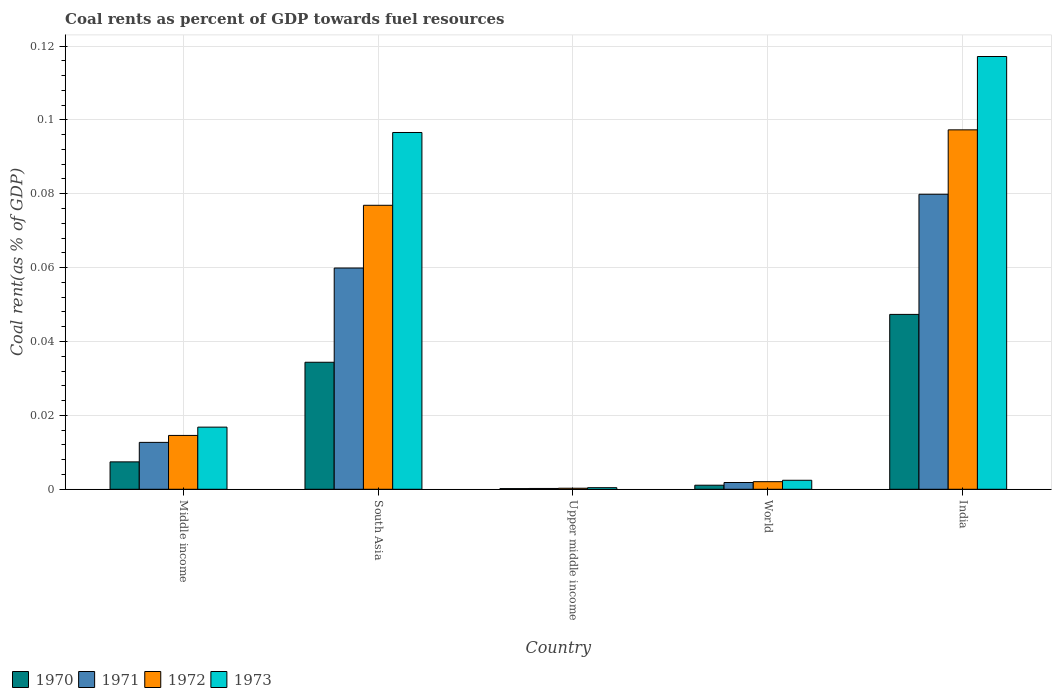How many different coloured bars are there?
Your response must be concise. 4. Are the number of bars per tick equal to the number of legend labels?
Provide a short and direct response. Yes. What is the coal rent in 1973 in Middle income?
Your answer should be compact. 0.02. Across all countries, what is the maximum coal rent in 1971?
Your response must be concise. 0.08. Across all countries, what is the minimum coal rent in 1971?
Your answer should be compact. 0. In which country was the coal rent in 1971 maximum?
Give a very brief answer. India. In which country was the coal rent in 1971 minimum?
Your response must be concise. Upper middle income. What is the total coal rent in 1972 in the graph?
Give a very brief answer. 0.19. What is the difference between the coal rent in 1973 in Middle income and that in South Asia?
Keep it short and to the point. -0.08. What is the difference between the coal rent in 1970 in South Asia and the coal rent in 1972 in India?
Ensure brevity in your answer.  -0.06. What is the average coal rent in 1972 per country?
Give a very brief answer. 0.04. What is the difference between the coal rent of/in 1970 and coal rent of/in 1973 in Middle income?
Your answer should be very brief. -0.01. What is the ratio of the coal rent in 1972 in India to that in Middle income?
Offer a very short reply. 6.68. What is the difference between the highest and the second highest coal rent in 1971?
Your answer should be very brief. 0.07. What is the difference between the highest and the lowest coal rent in 1971?
Offer a terse response. 0.08. In how many countries, is the coal rent in 1971 greater than the average coal rent in 1971 taken over all countries?
Keep it short and to the point. 2. Is the sum of the coal rent in 1973 in India and Upper middle income greater than the maximum coal rent in 1970 across all countries?
Keep it short and to the point. Yes. Is it the case that in every country, the sum of the coal rent in 1970 and coal rent in 1973 is greater than the coal rent in 1971?
Make the answer very short. Yes. How many bars are there?
Make the answer very short. 20. How many countries are there in the graph?
Offer a very short reply. 5. What is the difference between two consecutive major ticks on the Y-axis?
Provide a succinct answer. 0.02. Are the values on the major ticks of Y-axis written in scientific E-notation?
Give a very brief answer. No. Does the graph contain grids?
Offer a very short reply. Yes. How are the legend labels stacked?
Your answer should be very brief. Horizontal. What is the title of the graph?
Ensure brevity in your answer.  Coal rents as percent of GDP towards fuel resources. Does "2012" appear as one of the legend labels in the graph?
Your answer should be compact. No. What is the label or title of the X-axis?
Give a very brief answer. Country. What is the label or title of the Y-axis?
Provide a short and direct response. Coal rent(as % of GDP). What is the Coal rent(as % of GDP) of 1970 in Middle income?
Make the answer very short. 0.01. What is the Coal rent(as % of GDP) in 1971 in Middle income?
Make the answer very short. 0.01. What is the Coal rent(as % of GDP) of 1972 in Middle income?
Provide a succinct answer. 0.01. What is the Coal rent(as % of GDP) in 1973 in Middle income?
Give a very brief answer. 0.02. What is the Coal rent(as % of GDP) in 1970 in South Asia?
Your response must be concise. 0.03. What is the Coal rent(as % of GDP) of 1971 in South Asia?
Keep it short and to the point. 0.06. What is the Coal rent(as % of GDP) in 1972 in South Asia?
Offer a very short reply. 0.08. What is the Coal rent(as % of GDP) of 1973 in South Asia?
Make the answer very short. 0.1. What is the Coal rent(as % of GDP) in 1970 in Upper middle income?
Provide a short and direct response. 0. What is the Coal rent(as % of GDP) in 1971 in Upper middle income?
Offer a very short reply. 0. What is the Coal rent(as % of GDP) of 1972 in Upper middle income?
Provide a succinct answer. 0. What is the Coal rent(as % of GDP) in 1973 in Upper middle income?
Keep it short and to the point. 0. What is the Coal rent(as % of GDP) of 1970 in World?
Provide a succinct answer. 0. What is the Coal rent(as % of GDP) of 1971 in World?
Your response must be concise. 0. What is the Coal rent(as % of GDP) in 1972 in World?
Make the answer very short. 0. What is the Coal rent(as % of GDP) of 1973 in World?
Keep it short and to the point. 0. What is the Coal rent(as % of GDP) in 1970 in India?
Keep it short and to the point. 0.05. What is the Coal rent(as % of GDP) in 1971 in India?
Provide a short and direct response. 0.08. What is the Coal rent(as % of GDP) in 1972 in India?
Your answer should be compact. 0.1. What is the Coal rent(as % of GDP) of 1973 in India?
Provide a short and direct response. 0.12. Across all countries, what is the maximum Coal rent(as % of GDP) in 1970?
Give a very brief answer. 0.05. Across all countries, what is the maximum Coal rent(as % of GDP) in 1971?
Provide a succinct answer. 0.08. Across all countries, what is the maximum Coal rent(as % of GDP) of 1972?
Provide a succinct answer. 0.1. Across all countries, what is the maximum Coal rent(as % of GDP) in 1973?
Keep it short and to the point. 0.12. Across all countries, what is the minimum Coal rent(as % of GDP) of 1970?
Provide a short and direct response. 0. Across all countries, what is the minimum Coal rent(as % of GDP) of 1971?
Give a very brief answer. 0. Across all countries, what is the minimum Coal rent(as % of GDP) of 1972?
Offer a terse response. 0. Across all countries, what is the minimum Coal rent(as % of GDP) of 1973?
Keep it short and to the point. 0. What is the total Coal rent(as % of GDP) in 1970 in the graph?
Your answer should be very brief. 0.09. What is the total Coal rent(as % of GDP) of 1971 in the graph?
Your answer should be very brief. 0.15. What is the total Coal rent(as % of GDP) of 1972 in the graph?
Keep it short and to the point. 0.19. What is the total Coal rent(as % of GDP) of 1973 in the graph?
Keep it short and to the point. 0.23. What is the difference between the Coal rent(as % of GDP) in 1970 in Middle income and that in South Asia?
Your answer should be very brief. -0.03. What is the difference between the Coal rent(as % of GDP) of 1971 in Middle income and that in South Asia?
Your answer should be compact. -0.05. What is the difference between the Coal rent(as % of GDP) in 1972 in Middle income and that in South Asia?
Provide a succinct answer. -0.06. What is the difference between the Coal rent(as % of GDP) in 1973 in Middle income and that in South Asia?
Provide a succinct answer. -0.08. What is the difference between the Coal rent(as % of GDP) in 1970 in Middle income and that in Upper middle income?
Give a very brief answer. 0.01. What is the difference between the Coal rent(as % of GDP) in 1971 in Middle income and that in Upper middle income?
Offer a terse response. 0.01. What is the difference between the Coal rent(as % of GDP) of 1972 in Middle income and that in Upper middle income?
Offer a terse response. 0.01. What is the difference between the Coal rent(as % of GDP) of 1973 in Middle income and that in Upper middle income?
Offer a very short reply. 0.02. What is the difference between the Coal rent(as % of GDP) of 1970 in Middle income and that in World?
Ensure brevity in your answer.  0.01. What is the difference between the Coal rent(as % of GDP) in 1971 in Middle income and that in World?
Keep it short and to the point. 0.01. What is the difference between the Coal rent(as % of GDP) of 1972 in Middle income and that in World?
Make the answer very short. 0.01. What is the difference between the Coal rent(as % of GDP) of 1973 in Middle income and that in World?
Offer a terse response. 0.01. What is the difference between the Coal rent(as % of GDP) in 1970 in Middle income and that in India?
Ensure brevity in your answer.  -0.04. What is the difference between the Coal rent(as % of GDP) in 1971 in Middle income and that in India?
Keep it short and to the point. -0.07. What is the difference between the Coal rent(as % of GDP) in 1972 in Middle income and that in India?
Offer a terse response. -0.08. What is the difference between the Coal rent(as % of GDP) of 1973 in Middle income and that in India?
Offer a very short reply. -0.1. What is the difference between the Coal rent(as % of GDP) of 1970 in South Asia and that in Upper middle income?
Keep it short and to the point. 0.03. What is the difference between the Coal rent(as % of GDP) in 1971 in South Asia and that in Upper middle income?
Make the answer very short. 0.06. What is the difference between the Coal rent(as % of GDP) in 1972 in South Asia and that in Upper middle income?
Keep it short and to the point. 0.08. What is the difference between the Coal rent(as % of GDP) in 1973 in South Asia and that in Upper middle income?
Keep it short and to the point. 0.1. What is the difference between the Coal rent(as % of GDP) of 1971 in South Asia and that in World?
Offer a terse response. 0.06. What is the difference between the Coal rent(as % of GDP) in 1972 in South Asia and that in World?
Your answer should be very brief. 0.07. What is the difference between the Coal rent(as % of GDP) of 1973 in South Asia and that in World?
Give a very brief answer. 0.09. What is the difference between the Coal rent(as % of GDP) of 1970 in South Asia and that in India?
Make the answer very short. -0.01. What is the difference between the Coal rent(as % of GDP) of 1971 in South Asia and that in India?
Make the answer very short. -0.02. What is the difference between the Coal rent(as % of GDP) in 1972 in South Asia and that in India?
Give a very brief answer. -0.02. What is the difference between the Coal rent(as % of GDP) in 1973 in South Asia and that in India?
Your answer should be very brief. -0.02. What is the difference between the Coal rent(as % of GDP) in 1970 in Upper middle income and that in World?
Keep it short and to the point. -0. What is the difference between the Coal rent(as % of GDP) of 1971 in Upper middle income and that in World?
Your response must be concise. -0. What is the difference between the Coal rent(as % of GDP) of 1972 in Upper middle income and that in World?
Give a very brief answer. -0. What is the difference between the Coal rent(as % of GDP) of 1973 in Upper middle income and that in World?
Offer a terse response. -0. What is the difference between the Coal rent(as % of GDP) in 1970 in Upper middle income and that in India?
Give a very brief answer. -0.05. What is the difference between the Coal rent(as % of GDP) in 1971 in Upper middle income and that in India?
Provide a short and direct response. -0.08. What is the difference between the Coal rent(as % of GDP) in 1972 in Upper middle income and that in India?
Provide a short and direct response. -0.1. What is the difference between the Coal rent(as % of GDP) of 1973 in Upper middle income and that in India?
Give a very brief answer. -0.12. What is the difference between the Coal rent(as % of GDP) of 1970 in World and that in India?
Ensure brevity in your answer.  -0.05. What is the difference between the Coal rent(as % of GDP) of 1971 in World and that in India?
Offer a very short reply. -0.08. What is the difference between the Coal rent(as % of GDP) in 1972 in World and that in India?
Your answer should be compact. -0.1. What is the difference between the Coal rent(as % of GDP) in 1973 in World and that in India?
Offer a very short reply. -0.11. What is the difference between the Coal rent(as % of GDP) of 1970 in Middle income and the Coal rent(as % of GDP) of 1971 in South Asia?
Provide a succinct answer. -0.05. What is the difference between the Coal rent(as % of GDP) in 1970 in Middle income and the Coal rent(as % of GDP) in 1972 in South Asia?
Provide a succinct answer. -0.07. What is the difference between the Coal rent(as % of GDP) of 1970 in Middle income and the Coal rent(as % of GDP) of 1973 in South Asia?
Your response must be concise. -0.09. What is the difference between the Coal rent(as % of GDP) in 1971 in Middle income and the Coal rent(as % of GDP) in 1972 in South Asia?
Offer a terse response. -0.06. What is the difference between the Coal rent(as % of GDP) of 1971 in Middle income and the Coal rent(as % of GDP) of 1973 in South Asia?
Offer a very short reply. -0.08. What is the difference between the Coal rent(as % of GDP) in 1972 in Middle income and the Coal rent(as % of GDP) in 1973 in South Asia?
Give a very brief answer. -0.08. What is the difference between the Coal rent(as % of GDP) of 1970 in Middle income and the Coal rent(as % of GDP) of 1971 in Upper middle income?
Provide a short and direct response. 0.01. What is the difference between the Coal rent(as % of GDP) of 1970 in Middle income and the Coal rent(as % of GDP) of 1972 in Upper middle income?
Ensure brevity in your answer.  0.01. What is the difference between the Coal rent(as % of GDP) in 1970 in Middle income and the Coal rent(as % of GDP) in 1973 in Upper middle income?
Provide a short and direct response. 0.01. What is the difference between the Coal rent(as % of GDP) of 1971 in Middle income and the Coal rent(as % of GDP) of 1972 in Upper middle income?
Give a very brief answer. 0.01. What is the difference between the Coal rent(as % of GDP) of 1971 in Middle income and the Coal rent(as % of GDP) of 1973 in Upper middle income?
Your answer should be compact. 0.01. What is the difference between the Coal rent(as % of GDP) of 1972 in Middle income and the Coal rent(as % of GDP) of 1973 in Upper middle income?
Offer a very short reply. 0.01. What is the difference between the Coal rent(as % of GDP) of 1970 in Middle income and the Coal rent(as % of GDP) of 1971 in World?
Make the answer very short. 0.01. What is the difference between the Coal rent(as % of GDP) of 1970 in Middle income and the Coal rent(as % of GDP) of 1972 in World?
Offer a very short reply. 0.01. What is the difference between the Coal rent(as % of GDP) of 1970 in Middle income and the Coal rent(as % of GDP) of 1973 in World?
Your answer should be compact. 0.01. What is the difference between the Coal rent(as % of GDP) of 1971 in Middle income and the Coal rent(as % of GDP) of 1972 in World?
Your answer should be very brief. 0.01. What is the difference between the Coal rent(as % of GDP) in 1971 in Middle income and the Coal rent(as % of GDP) in 1973 in World?
Offer a terse response. 0.01. What is the difference between the Coal rent(as % of GDP) in 1972 in Middle income and the Coal rent(as % of GDP) in 1973 in World?
Ensure brevity in your answer.  0.01. What is the difference between the Coal rent(as % of GDP) in 1970 in Middle income and the Coal rent(as % of GDP) in 1971 in India?
Provide a short and direct response. -0.07. What is the difference between the Coal rent(as % of GDP) of 1970 in Middle income and the Coal rent(as % of GDP) of 1972 in India?
Your answer should be compact. -0.09. What is the difference between the Coal rent(as % of GDP) of 1970 in Middle income and the Coal rent(as % of GDP) of 1973 in India?
Ensure brevity in your answer.  -0.11. What is the difference between the Coal rent(as % of GDP) of 1971 in Middle income and the Coal rent(as % of GDP) of 1972 in India?
Offer a terse response. -0.08. What is the difference between the Coal rent(as % of GDP) in 1971 in Middle income and the Coal rent(as % of GDP) in 1973 in India?
Your answer should be compact. -0.1. What is the difference between the Coal rent(as % of GDP) of 1972 in Middle income and the Coal rent(as % of GDP) of 1973 in India?
Keep it short and to the point. -0.1. What is the difference between the Coal rent(as % of GDP) of 1970 in South Asia and the Coal rent(as % of GDP) of 1971 in Upper middle income?
Keep it short and to the point. 0.03. What is the difference between the Coal rent(as % of GDP) of 1970 in South Asia and the Coal rent(as % of GDP) of 1972 in Upper middle income?
Keep it short and to the point. 0.03. What is the difference between the Coal rent(as % of GDP) in 1970 in South Asia and the Coal rent(as % of GDP) in 1973 in Upper middle income?
Provide a succinct answer. 0.03. What is the difference between the Coal rent(as % of GDP) of 1971 in South Asia and the Coal rent(as % of GDP) of 1972 in Upper middle income?
Offer a very short reply. 0.06. What is the difference between the Coal rent(as % of GDP) of 1971 in South Asia and the Coal rent(as % of GDP) of 1973 in Upper middle income?
Offer a very short reply. 0.06. What is the difference between the Coal rent(as % of GDP) of 1972 in South Asia and the Coal rent(as % of GDP) of 1973 in Upper middle income?
Your response must be concise. 0.08. What is the difference between the Coal rent(as % of GDP) in 1970 in South Asia and the Coal rent(as % of GDP) in 1971 in World?
Give a very brief answer. 0.03. What is the difference between the Coal rent(as % of GDP) of 1970 in South Asia and the Coal rent(as % of GDP) of 1972 in World?
Your answer should be compact. 0.03. What is the difference between the Coal rent(as % of GDP) in 1970 in South Asia and the Coal rent(as % of GDP) in 1973 in World?
Your answer should be compact. 0.03. What is the difference between the Coal rent(as % of GDP) of 1971 in South Asia and the Coal rent(as % of GDP) of 1972 in World?
Ensure brevity in your answer.  0.06. What is the difference between the Coal rent(as % of GDP) in 1971 in South Asia and the Coal rent(as % of GDP) in 1973 in World?
Provide a succinct answer. 0.06. What is the difference between the Coal rent(as % of GDP) of 1972 in South Asia and the Coal rent(as % of GDP) of 1973 in World?
Offer a terse response. 0.07. What is the difference between the Coal rent(as % of GDP) in 1970 in South Asia and the Coal rent(as % of GDP) in 1971 in India?
Keep it short and to the point. -0.05. What is the difference between the Coal rent(as % of GDP) of 1970 in South Asia and the Coal rent(as % of GDP) of 1972 in India?
Make the answer very short. -0.06. What is the difference between the Coal rent(as % of GDP) in 1970 in South Asia and the Coal rent(as % of GDP) in 1973 in India?
Offer a very short reply. -0.08. What is the difference between the Coal rent(as % of GDP) of 1971 in South Asia and the Coal rent(as % of GDP) of 1972 in India?
Offer a terse response. -0.04. What is the difference between the Coal rent(as % of GDP) of 1971 in South Asia and the Coal rent(as % of GDP) of 1973 in India?
Give a very brief answer. -0.06. What is the difference between the Coal rent(as % of GDP) in 1972 in South Asia and the Coal rent(as % of GDP) in 1973 in India?
Your response must be concise. -0.04. What is the difference between the Coal rent(as % of GDP) of 1970 in Upper middle income and the Coal rent(as % of GDP) of 1971 in World?
Ensure brevity in your answer.  -0. What is the difference between the Coal rent(as % of GDP) of 1970 in Upper middle income and the Coal rent(as % of GDP) of 1972 in World?
Offer a terse response. -0. What is the difference between the Coal rent(as % of GDP) in 1970 in Upper middle income and the Coal rent(as % of GDP) in 1973 in World?
Provide a short and direct response. -0. What is the difference between the Coal rent(as % of GDP) of 1971 in Upper middle income and the Coal rent(as % of GDP) of 1972 in World?
Make the answer very short. -0. What is the difference between the Coal rent(as % of GDP) in 1971 in Upper middle income and the Coal rent(as % of GDP) in 1973 in World?
Give a very brief answer. -0. What is the difference between the Coal rent(as % of GDP) of 1972 in Upper middle income and the Coal rent(as % of GDP) of 1973 in World?
Give a very brief answer. -0. What is the difference between the Coal rent(as % of GDP) of 1970 in Upper middle income and the Coal rent(as % of GDP) of 1971 in India?
Provide a short and direct response. -0.08. What is the difference between the Coal rent(as % of GDP) of 1970 in Upper middle income and the Coal rent(as % of GDP) of 1972 in India?
Make the answer very short. -0.1. What is the difference between the Coal rent(as % of GDP) of 1970 in Upper middle income and the Coal rent(as % of GDP) of 1973 in India?
Offer a terse response. -0.12. What is the difference between the Coal rent(as % of GDP) in 1971 in Upper middle income and the Coal rent(as % of GDP) in 1972 in India?
Ensure brevity in your answer.  -0.1. What is the difference between the Coal rent(as % of GDP) of 1971 in Upper middle income and the Coal rent(as % of GDP) of 1973 in India?
Keep it short and to the point. -0.12. What is the difference between the Coal rent(as % of GDP) of 1972 in Upper middle income and the Coal rent(as % of GDP) of 1973 in India?
Give a very brief answer. -0.12. What is the difference between the Coal rent(as % of GDP) of 1970 in World and the Coal rent(as % of GDP) of 1971 in India?
Ensure brevity in your answer.  -0.08. What is the difference between the Coal rent(as % of GDP) in 1970 in World and the Coal rent(as % of GDP) in 1972 in India?
Your answer should be compact. -0.1. What is the difference between the Coal rent(as % of GDP) in 1970 in World and the Coal rent(as % of GDP) in 1973 in India?
Ensure brevity in your answer.  -0.12. What is the difference between the Coal rent(as % of GDP) in 1971 in World and the Coal rent(as % of GDP) in 1972 in India?
Your response must be concise. -0.1. What is the difference between the Coal rent(as % of GDP) in 1971 in World and the Coal rent(as % of GDP) in 1973 in India?
Ensure brevity in your answer.  -0.12. What is the difference between the Coal rent(as % of GDP) in 1972 in World and the Coal rent(as % of GDP) in 1973 in India?
Ensure brevity in your answer.  -0.12. What is the average Coal rent(as % of GDP) in 1970 per country?
Your answer should be compact. 0.02. What is the average Coal rent(as % of GDP) of 1971 per country?
Provide a succinct answer. 0.03. What is the average Coal rent(as % of GDP) of 1972 per country?
Make the answer very short. 0.04. What is the average Coal rent(as % of GDP) in 1973 per country?
Offer a terse response. 0.05. What is the difference between the Coal rent(as % of GDP) in 1970 and Coal rent(as % of GDP) in 1971 in Middle income?
Your answer should be very brief. -0.01. What is the difference between the Coal rent(as % of GDP) of 1970 and Coal rent(as % of GDP) of 1972 in Middle income?
Provide a short and direct response. -0.01. What is the difference between the Coal rent(as % of GDP) in 1970 and Coal rent(as % of GDP) in 1973 in Middle income?
Keep it short and to the point. -0.01. What is the difference between the Coal rent(as % of GDP) in 1971 and Coal rent(as % of GDP) in 1972 in Middle income?
Your answer should be compact. -0. What is the difference between the Coal rent(as % of GDP) of 1971 and Coal rent(as % of GDP) of 1973 in Middle income?
Your answer should be compact. -0. What is the difference between the Coal rent(as % of GDP) in 1972 and Coal rent(as % of GDP) in 1973 in Middle income?
Make the answer very short. -0. What is the difference between the Coal rent(as % of GDP) in 1970 and Coal rent(as % of GDP) in 1971 in South Asia?
Provide a short and direct response. -0.03. What is the difference between the Coal rent(as % of GDP) of 1970 and Coal rent(as % of GDP) of 1972 in South Asia?
Make the answer very short. -0.04. What is the difference between the Coal rent(as % of GDP) in 1970 and Coal rent(as % of GDP) in 1973 in South Asia?
Keep it short and to the point. -0.06. What is the difference between the Coal rent(as % of GDP) of 1971 and Coal rent(as % of GDP) of 1972 in South Asia?
Make the answer very short. -0.02. What is the difference between the Coal rent(as % of GDP) of 1971 and Coal rent(as % of GDP) of 1973 in South Asia?
Your response must be concise. -0.04. What is the difference between the Coal rent(as % of GDP) of 1972 and Coal rent(as % of GDP) of 1973 in South Asia?
Your answer should be compact. -0.02. What is the difference between the Coal rent(as % of GDP) of 1970 and Coal rent(as % of GDP) of 1972 in Upper middle income?
Your answer should be very brief. -0. What is the difference between the Coal rent(as % of GDP) in 1970 and Coal rent(as % of GDP) in 1973 in Upper middle income?
Your answer should be very brief. -0. What is the difference between the Coal rent(as % of GDP) in 1971 and Coal rent(as % of GDP) in 1972 in Upper middle income?
Give a very brief answer. -0. What is the difference between the Coal rent(as % of GDP) of 1971 and Coal rent(as % of GDP) of 1973 in Upper middle income?
Provide a succinct answer. -0. What is the difference between the Coal rent(as % of GDP) in 1972 and Coal rent(as % of GDP) in 1973 in Upper middle income?
Offer a very short reply. -0. What is the difference between the Coal rent(as % of GDP) of 1970 and Coal rent(as % of GDP) of 1971 in World?
Your answer should be compact. -0. What is the difference between the Coal rent(as % of GDP) in 1970 and Coal rent(as % of GDP) in 1972 in World?
Provide a succinct answer. -0. What is the difference between the Coal rent(as % of GDP) in 1970 and Coal rent(as % of GDP) in 1973 in World?
Provide a short and direct response. -0. What is the difference between the Coal rent(as % of GDP) of 1971 and Coal rent(as % of GDP) of 1972 in World?
Your answer should be compact. -0. What is the difference between the Coal rent(as % of GDP) of 1971 and Coal rent(as % of GDP) of 1973 in World?
Your answer should be very brief. -0. What is the difference between the Coal rent(as % of GDP) in 1972 and Coal rent(as % of GDP) in 1973 in World?
Keep it short and to the point. -0. What is the difference between the Coal rent(as % of GDP) in 1970 and Coal rent(as % of GDP) in 1971 in India?
Make the answer very short. -0.03. What is the difference between the Coal rent(as % of GDP) of 1970 and Coal rent(as % of GDP) of 1972 in India?
Keep it short and to the point. -0.05. What is the difference between the Coal rent(as % of GDP) in 1970 and Coal rent(as % of GDP) in 1973 in India?
Offer a very short reply. -0.07. What is the difference between the Coal rent(as % of GDP) in 1971 and Coal rent(as % of GDP) in 1972 in India?
Offer a very short reply. -0.02. What is the difference between the Coal rent(as % of GDP) of 1971 and Coal rent(as % of GDP) of 1973 in India?
Your answer should be compact. -0.04. What is the difference between the Coal rent(as % of GDP) of 1972 and Coal rent(as % of GDP) of 1973 in India?
Offer a terse response. -0.02. What is the ratio of the Coal rent(as % of GDP) of 1970 in Middle income to that in South Asia?
Give a very brief answer. 0.22. What is the ratio of the Coal rent(as % of GDP) in 1971 in Middle income to that in South Asia?
Your answer should be very brief. 0.21. What is the ratio of the Coal rent(as % of GDP) of 1972 in Middle income to that in South Asia?
Your answer should be compact. 0.19. What is the ratio of the Coal rent(as % of GDP) in 1973 in Middle income to that in South Asia?
Offer a terse response. 0.17. What is the ratio of the Coal rent(as % of GDP) in 1970 in Middle income to that in Upper middle income?
Ensure brevity in your answer.  40.36. What is the ratio of the Coal rent(as % of GDP) in 1971 in Middle income to that in Upper middle income?
Offer a terse response. 58.01. What is the ratio of the Coal rent(as % of GDP) of 1972 in Middle income to that in Upper middle income?
Your answer should be compact. 51.25. What is the ratio of the Coal rent(as % of GDP) in 1973 in Middle income to that in Upper middle income?
Give a very brief answer. 39.04. What is the ratio of the Coal rent(as % of GDP) of 1970 in Middle income to that in World?
Offer a very short reply. 6.74. What is the ratio of the Coal rent(as % of GDP) in 1971 in Middle income to that in World?
Your answer should be compact. 6.93. What is the ratio of the Coal rent(as % of GDP) of 1972 in Middle income to that in World?
Offer a very short reply. 7.09. What is the ratio of the Coal rent(as % of GDP) in 1973 in Middle income to that in World?
Your answer should be compact. 6.91. What is the ratio of the Coal rent(as % of GDP) of 1970 in Middle income to that in India?
Keep it short and to the point. 0.16. What is the ratio of the Coal rent(as % of GDP) of 1971 in Middle income to that in India?
Your answer should be very brief. 0.16. What is the ratio of the Coal rent(as % of GDP) in 1972 in Middle income to that in India?
Give a very brief answer. 0.15. What is the ratio of the Coal rent(as % of GDP) of 1973 in Middle income to that in India?
Offer a terse response. 0.14. What is the ratio of the Coal rent(as % of GDP) in 1970 in South Asia to that in Upper middle income?
Keep it short and to the point. 187.05. What is the ratio of the Coal rent(as % of GDP) of 1971 in South Asia to that in Upper middle income?
Keep it short and to the point. 273.74. What is the ratio of the Coal rent(as % of GDP) of 1972 in South Asia to that in Upper middle income?
Your answer should be very brief. 270.32. What is the ratio of the Coal rent(as % of GDP) in 1973 in South Asia to that in Upper middle income?
Offer a terse response. 224.18. What is the ratio of the Coal rent(as % of GDP) of 1970 in South Asia to that in World?
Keep it short and to the point. 31.24. What is the ratio of the Coal rent(as % of GDP) in 1971 in South Asia to that in World?
Keep it short and to the point. 32.69. What is the ratio of the Coal rent(as % of GDP) in 1972 in South Asia to that in World?
Provide a succinct answer. 37.41. What is the ratio of the Coal rent(as % of GDP) of 1973 in South Asia to that in World?
Provide a succinct answer. 39.65. What is the ratio of the Coal rent(as % of GDP) in 1970 in South Asia to that in India?
Your response must be concise. 0.73. What is the ratio of the Coal rent(as % of GDP) in 1971 in South Asia to that in India?
Keep it short and to the point. 0.75. What is the ratio of the Coal rent(as % of GDP) of 1972 in South Asia to that in India?
Keep it short and to the point. 0.79. What is the ratio of the Coal rent(as % of GDP) in 1973 in South Asia to that in India?
Your response must be concise. 0.82. What is the ratio of the Coal rent(as % of GDP) in 1970 in Upper middle income to that in World?
Provide a short and direct response. 0.17. What is the ratio of the Coal rent(as % of GDP) in 1971 in Upper middle income to that in World?
Give a very brief answer. 0.12. What is the ratio of the Coal rent(as % of GDP) in 1972 in Upper middle income to that in World?
Offer a terse response. 0.14. What is the ratio of the Coal rent(as % of GDP) in 1973 in Upper middle income to that in World?
Offer a very short reply. 0.18. What is the ratio of the Coal rent(as % of GDP) in 1970 in Upper middle income to that in India?
Make the answer very short. 0. What is the ratio of the Coal rent(as % of GDP) in 1971 in Upper middle income to that in India?
Keep it short and to the point. 0. What is the ratio of the Coal rent(as % of GDP) in 1972 in Upper middle income to that in India?
Your answer should be compact. 0. What is the ratio of the Coal rent(as % of GDP) in 1973 in Upper middle income to that in India?
Keep it short and to the point. 0. What is the ratio of the Coal rent(as % of GDP) in 1970 in World to that in India?
Ensure brevity in your answer.  0.02. What is the ratio of the Coal rent(as % of GDP) of 1971 in World to that in India?
Make the answer very short. 0.02. What is the ratio of the Coal rent(as % of GDP) in 1972 in World to that in India?
Make the answer very short. 0.02. What is the ratio of the Coal rent(as % of GDP) of 1973 in World to that in India?
Make the answer very short. 0.02. What is the difference between the highest and the second highest Coal rent(as % of GDP) in 1970?
Provide a short and direct response. 0.01. What is the difference between the highest and the second highest Coal rent(as % of GDP) of 1971?
Your answer should be compact. 0.02. What is the difference between the highest and the second highest Coal rent(as % of GDP) in 1972?
Your response must be concise. 0.02. What is the difference between the highest and the second highest Coal rent(as % of GDP) in 1973?
Your answer should be compact. 0.02. What is the difference between the highest and the lowest Coal rent(as % of GDP) in 1970?
Your response must be concise. 0.05. What is the difference between the highest and the lowest Coal rent(as % of GDP) of 1971?
Your answer should be compact. 0.08. What is the difference between the highest and the lowest Coal rent(as % of GDP) in 1972?
Keep it short and to the point. 0.1. What is the difference between the highest and the lowest Coal rent(as % of GDP) of 1973?
Make the answer very short. 0.12. 